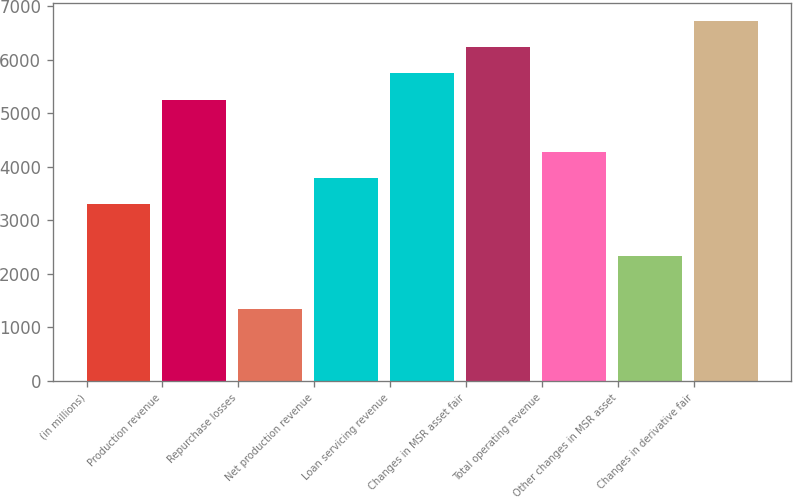<chart> <loc_0><loc_0><loc_500><loc_500><bar_chart><fcel>(in millions)<fcel>Production revenue<fcel>Repurchase losses<fcel>Net production revenue<fcel>Loan servicing revenue<fcel>Changes in MSR asset fair<fcel>Total operating revenue<fcel>Other changes in MSR asset<fcel>Changes in derivative fair<nl><fcel>3301.8<fcel>5256.6<fcel>1347<fcel>3790.5<fcel>5745.3<fcel>6234<fcel>4279.2<fcel>2324.4<fcel>6722.7<nl></chart> 